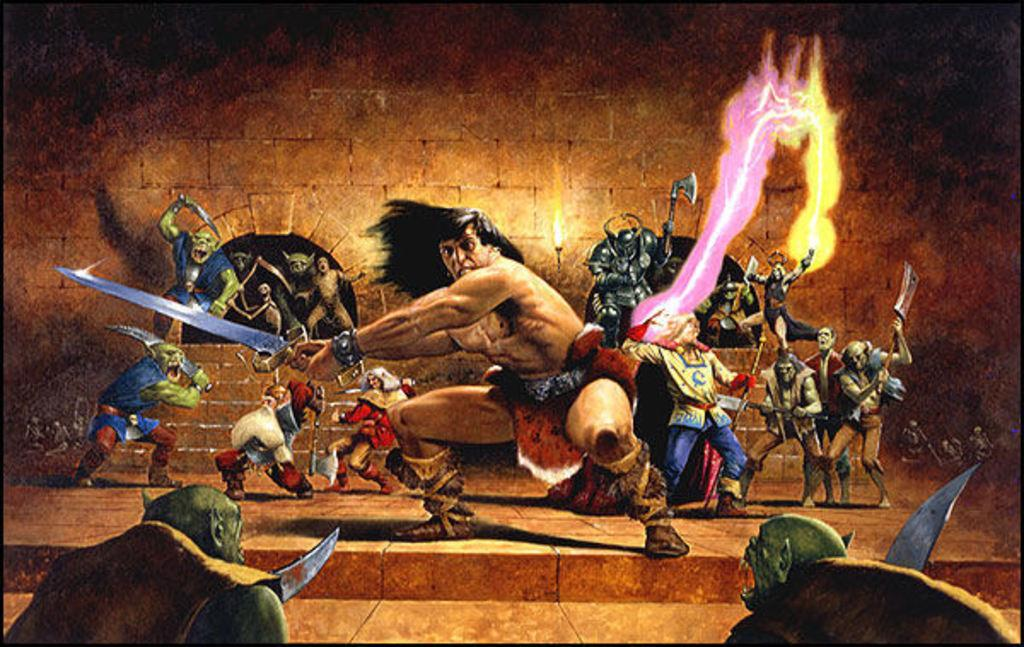What type of image is being described? The image is an animated picture. What are the people in the image doing? The people in the image are holding weapons. What can be seen in the background of the image? There is a wall and steps in the background of the image. What type of trains can be seen in the image? There are no trains present in the image; it features an animated scene with people holding weapons and a background with a wall and steps. 